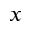<formula> <loc_0><loc_0><loc_500><loc_500>_ { x }</formula> 